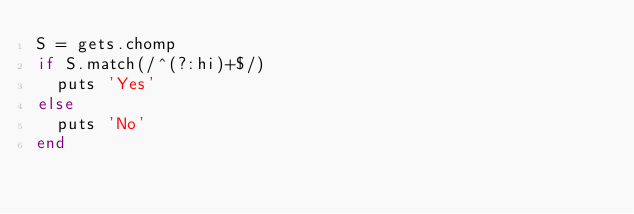Convert code to text. <code><loc_0><loc_0><loc_500><loc_500><_Ruby_>S = gets.chomp
if S.match(/^(?:hi)+$/)
  puts 'Yes'
else
  puts 'No'
end</code> 